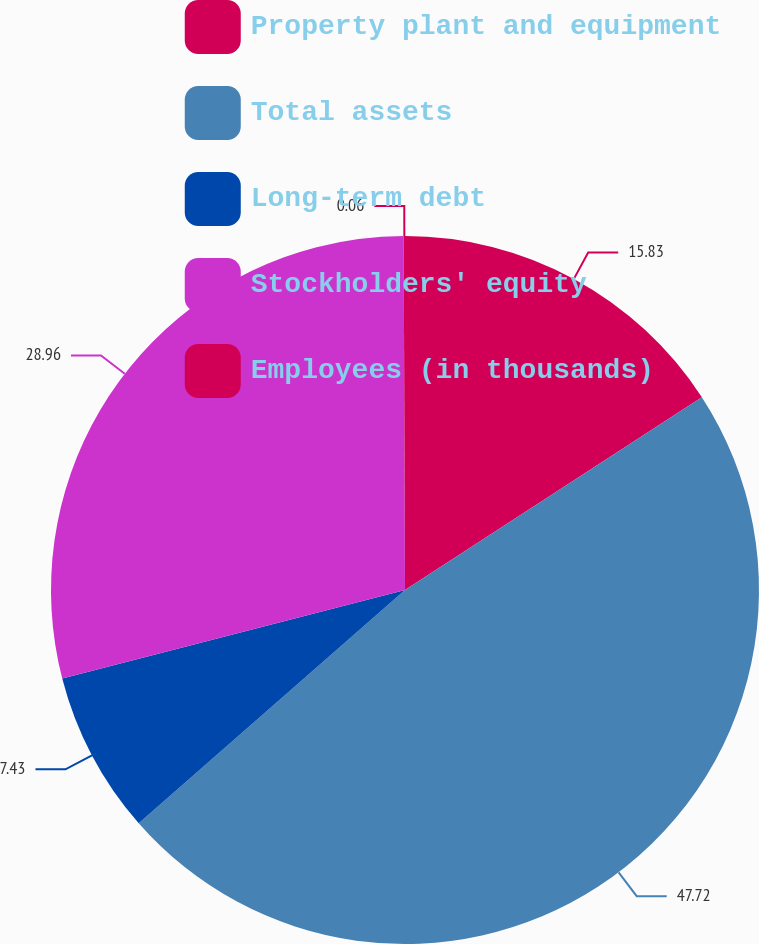Convert chart to OTSL. <chart><loc_0><loc_0><loc_500><loc_500><pie_chart><fcel>Property plant and equipment<fcel>Total assets<fcel>Long-term debt<fcel>Stockholders' equity<fcel>Employees (in thousands)<nl><fcel>15.83%<fcel>47.72%<fcel>7.43%<fcel>28.96%<fcel>0.06%<nl></chart> 